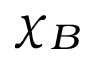Convert formula to latex. <formula><loc_0><loc_0><loc_500><loc_500>\chi _ { B }</formula> 